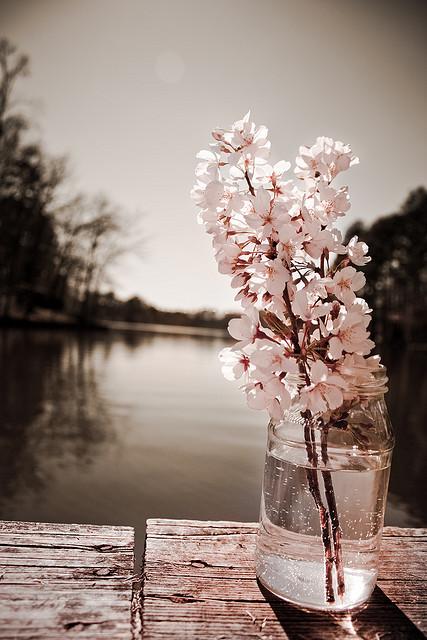Is a parking lot in the background?
Concise answer only. No. What color is the flower?
Concise answer only. Pink. Have all the flowers bloomed?
Keep it brief. Yes. What color are the flowers?
Short answer required. Pink. Are the blossoms real?
Give a very brief answer. Yes. What is in the bottom of the vase?
Concise answer only. Water. Are the flowers alive?
Concise answer only. Yes. 